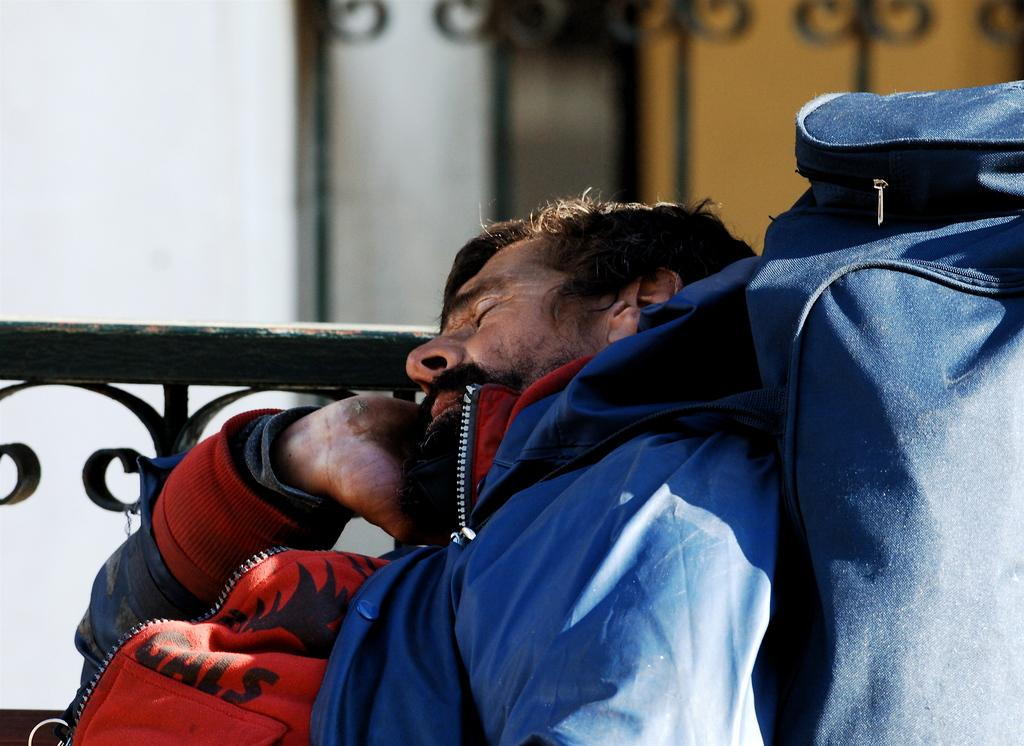Who is present in the image? There is a man in the image. What object can be seen with the man? There is a bag in the image. What structure is visible in the image? There is a fence in the image. Can you describe the background of the image? The background of the image is blurry. What type of pet is the man holding in the image? There is no pet visible in the image; only the man, a bag, and a fence are present. 